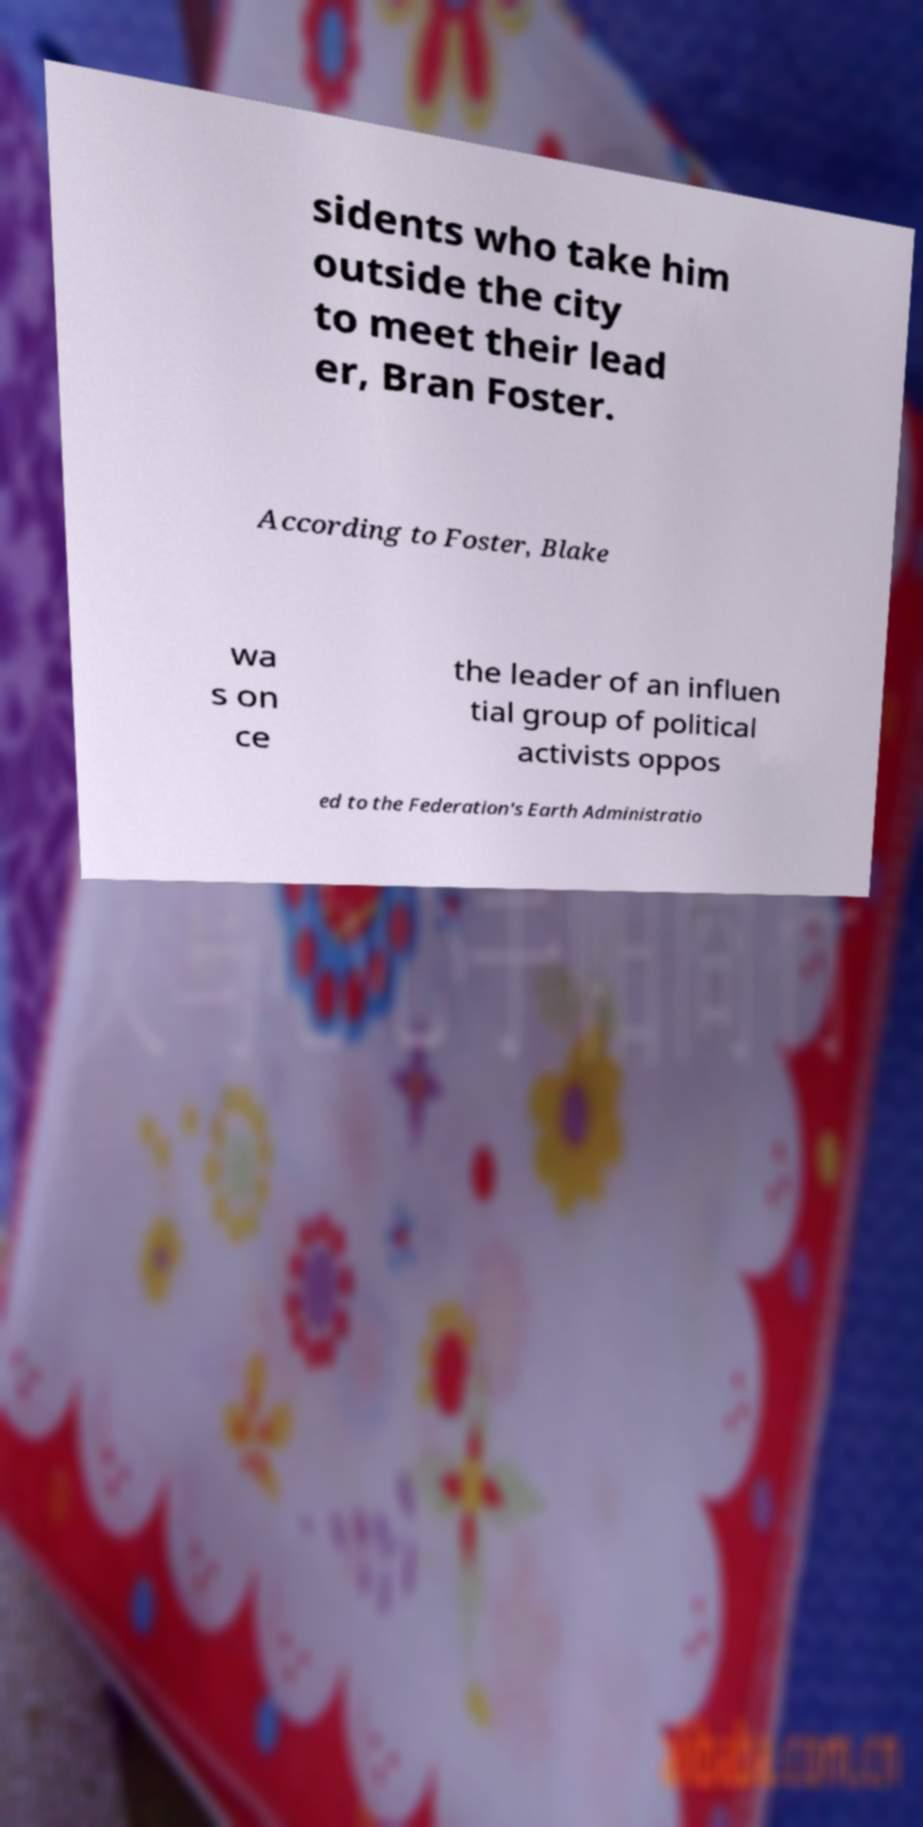Can you accurately transcribe the text from the provided image for me? sidents who take him outside the city to meet their lead er, Bran Foster. According to Foster, Blake wa s on ce the leader of an influen tial group of political activists oppos ed to the Federation's Earth Administratio 